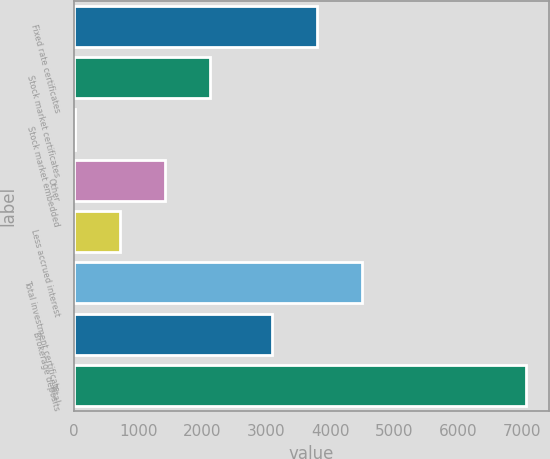Convert chart to OTSL. <chart><loc_0><loc_0><loc_500><loc_500><bar_chart><fcel>Fixed rate certificates<fcel>Stock market certificates<fcel>Stock market embedded<fcel>Other<fcel>Less accrued interest<fcel>Total investment certificate<fcel>Brokerage deposits<fcel>Total<nl><fcel>3793.5<fcel>2123.5<fcel>7<fcel>1418<fcel>712.5<fcel>4499<fcel>3088<fcel>7062<nl></chart> 